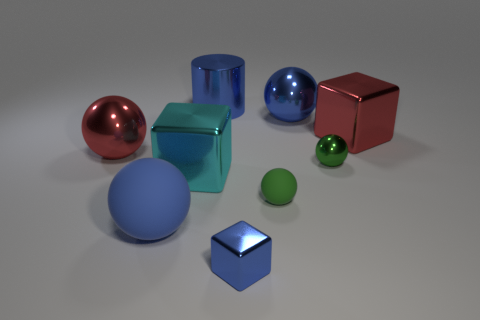There is a metal sphere that is right of the large matte thing and to the left of the green shiny thing; what color is it?
Ensure brevity in your answer.  Blue. What number of tiny things are spheres or cyan cubes?
Make the answer very short. 2. There is a blue metallic thing that is the same shape as the big blue matte thing; what is its size?
Give a very brief answer. Large. There is a green shiny thing; what shape is it?
Your answer should be very brief. Sphere. Are the cyan cube and the red object that is right of the cylinder made of the same material?
Your response must be concise. Yes. What number of matte objects are either large spheres or large blue cubes?
Provide a short and direct response. 1. What is the size of the blue thing that is in front of the blue matte object?
Your answer should be compact. Small. There is a cyan cube that is made of the same material as the large blue cylinder; what is its size?
Keep it short and to the point. Large. How many other big matte objects have the same color as the large rubber thing?
Offer a terse response. 0. Are any brown rubber cubes visible?
Make the answer very short. No. 